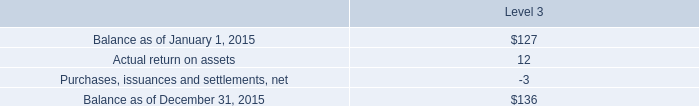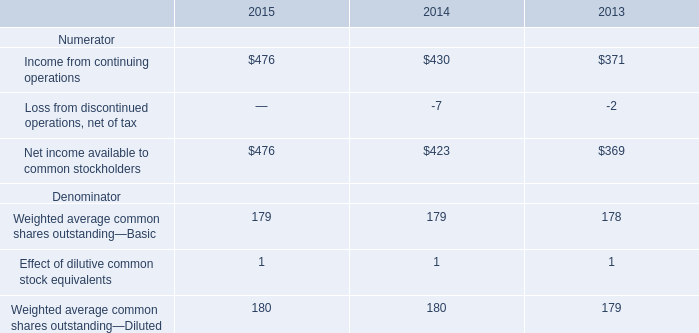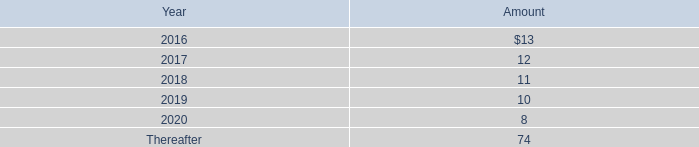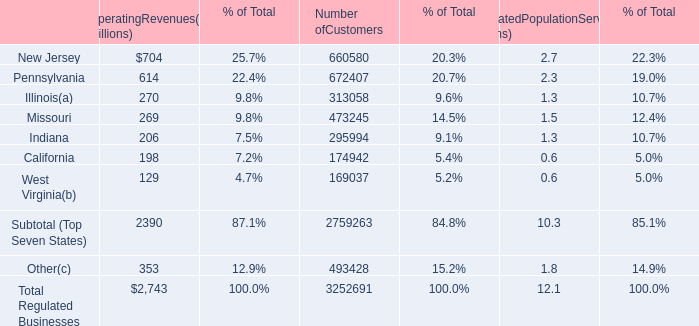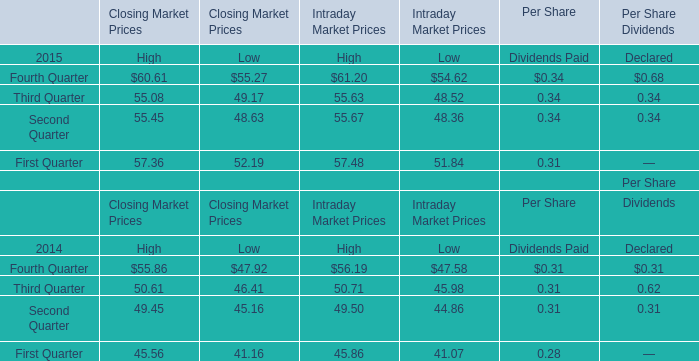In the year with lowest amount of Per Share Dividends Declared of Third Quarter, what's the increasing rate of Intraday Market High Prices of Fourth Quarter? 
Computations: ((61.20 - 56.19) / 56.19)
Answer: 0.08916. 